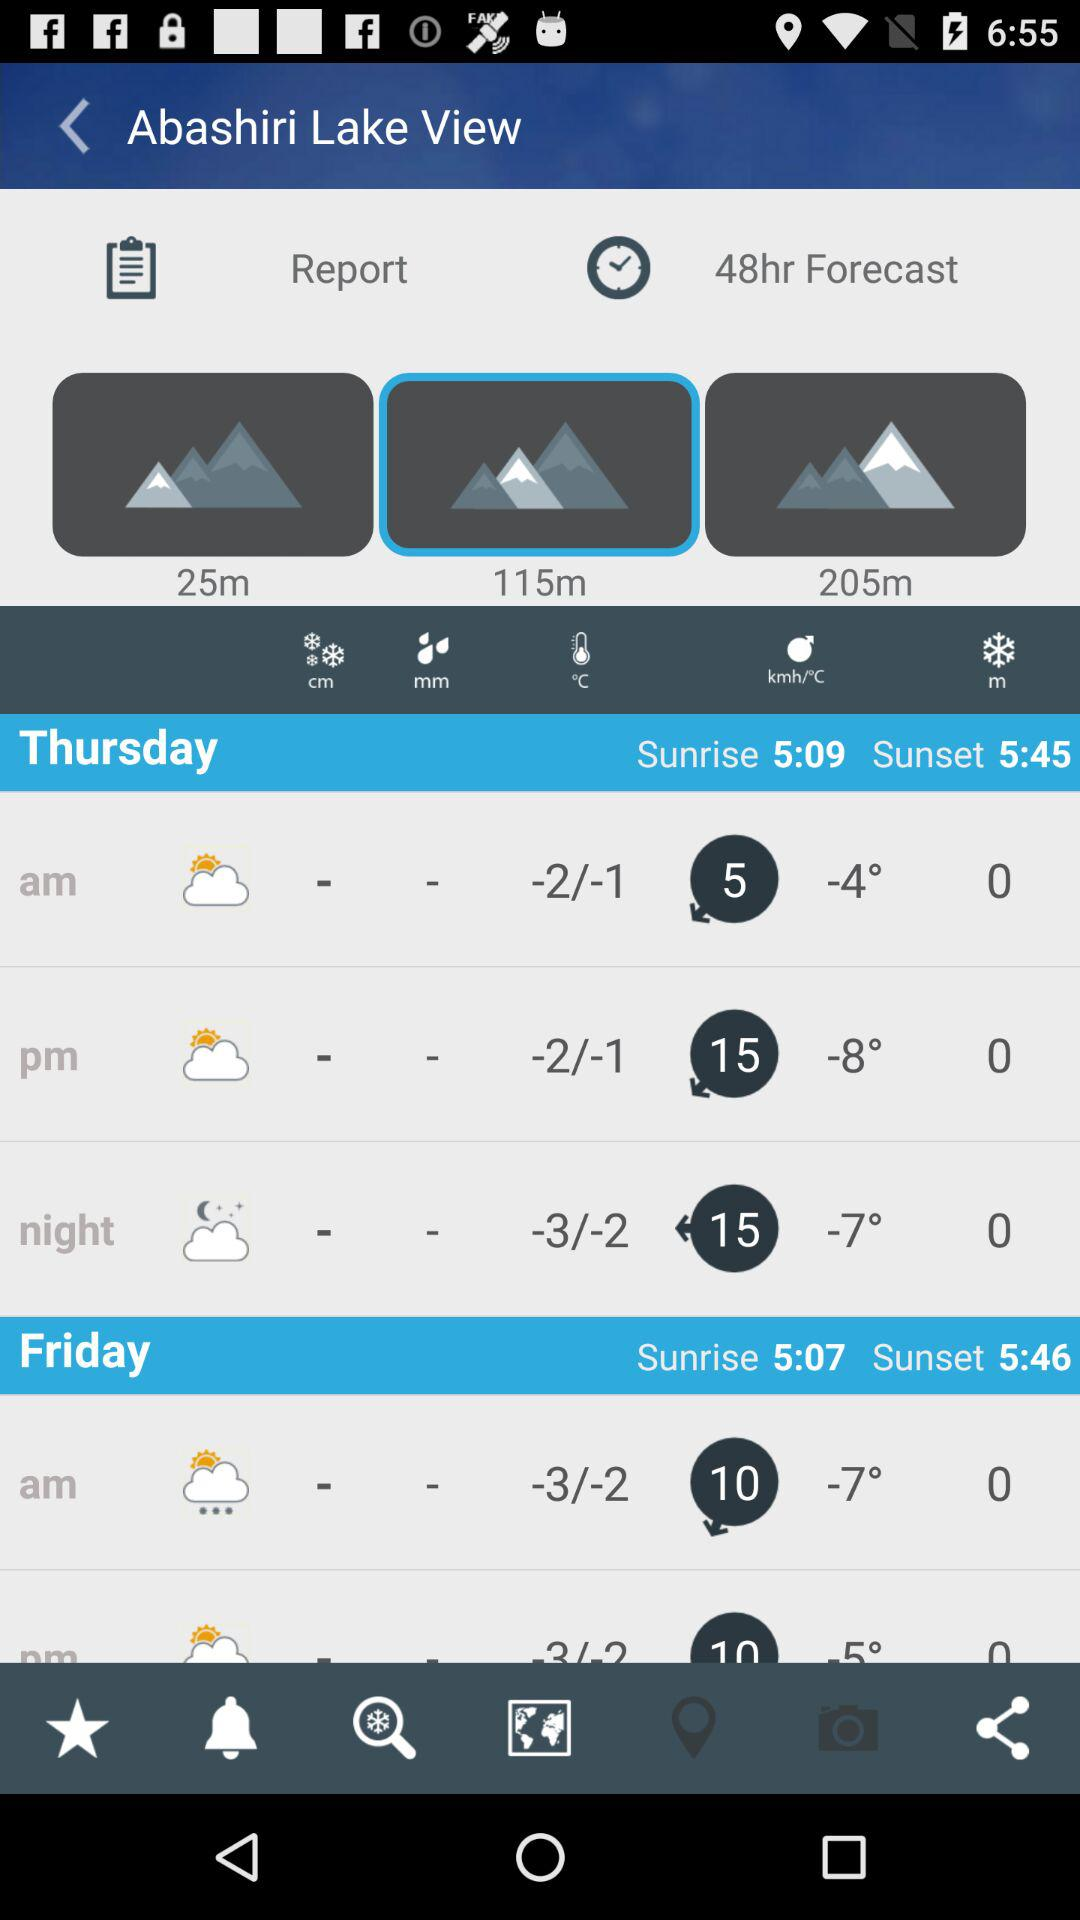What is the sunrise time on Thursday? The sunrise time is 5:09. 